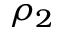Convert formula to latex. <formula><loc_0><loc_0><loc_500><loc_500>\rho _ { 2 }</formula> 